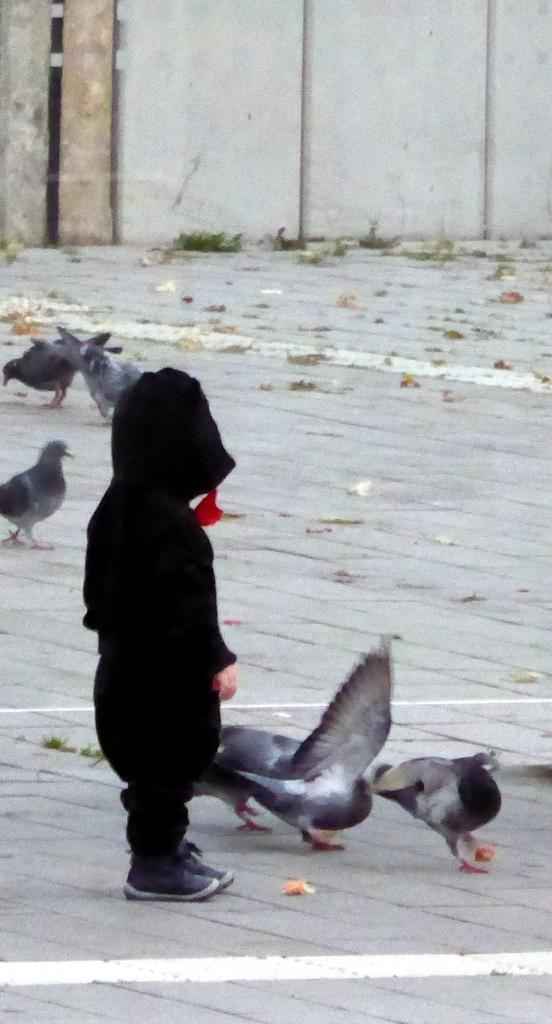Who is the main subject in the image? There is a child in the image. What is the child wearing? The child is wearing a black jacket. What other living creatures can be seen in the image? There are birds in the image. What can be seen in the background of the image? There is a building in the background of the image. What type of mark can be seen on the child's face in the image? There is no mark visible on the child's face in the image. Is there a tent present in the image? No, there is no tent present in the image. 